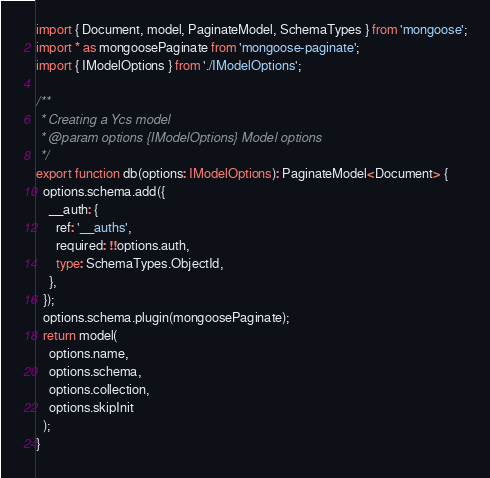Convert code to text. <code><loc_0><loc_0><loc_500><loc_500><_TypeScript_>import { Document, model, PaginateModel, SchemaTypes } from 'mongoose';
import * as mongoosePaginate from 'mongoose-paginate';
import { IModelOptions } from './IModelOptions';

/**
 * Creating a Ycs model
 * @param options {IModelOptions} Model options
 */
export function db(options: IModelOptions): PaginateModel<Document> {
  options.schema.add({
    __auth: {
      ref: '__auths',
      required: !!options.auth,
      type: SchemaTypes.ObjectId,
    },
  });
  options.schema.plugin(mongoosePaginate);
  return model(
    options.name,
    options.schema,
    options.collection,
    options.skipInit
  );
}
</code> 